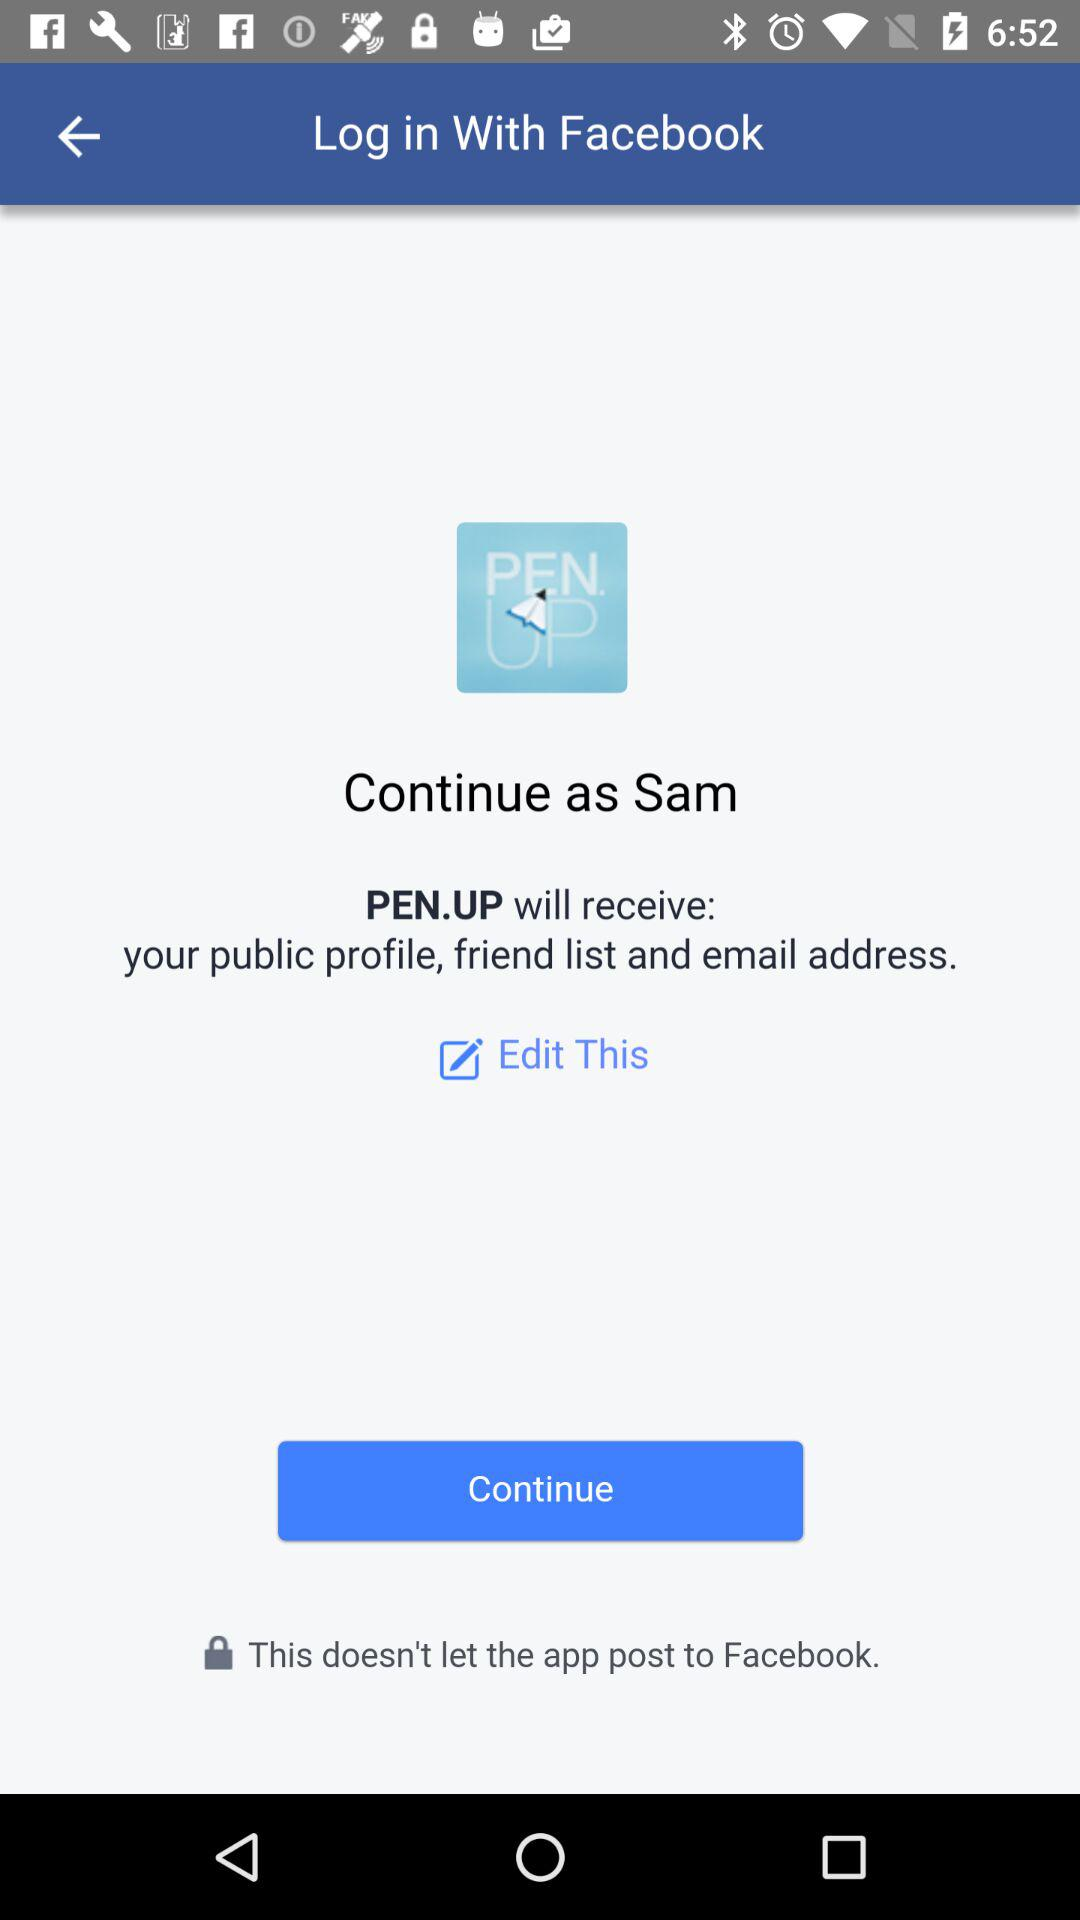What is the user's last name?
When the provided information is insufficient, respond with <no answer>. <no answer> 